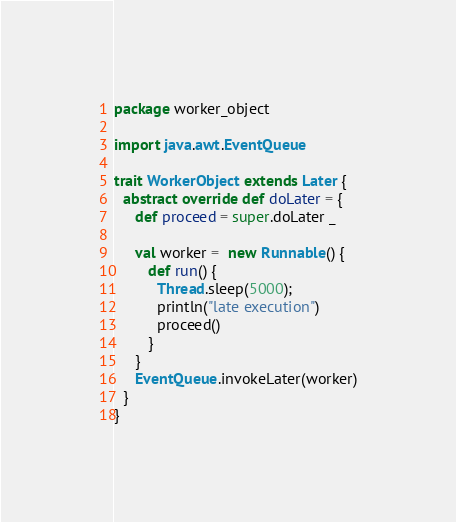<code> <loc_0><loc_0><loc_500><loc_500><_Scala_>package worker_object

import java.awt.EventQueue

trait WorkerObject extends Later {
  abstract override def doLater = {
     def proceed = super.doLater _
    
     val worker =  new Runnable() {
		def run() {
		  Thread.sleep(5000);
		  println("late execution")
		  proceed()
		}
	 }
     EventQueue.invokeLater(worker)
  }
}</code> 